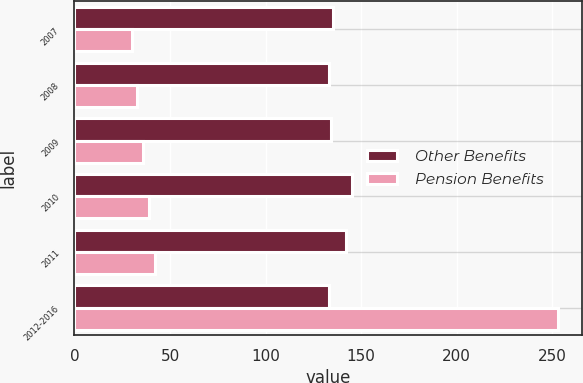Convert chart to OTSL. <chart><loc_0><loc_0><loc_500><loc_500><stacked_bar_chart><ecel><fcel>2007<fcel>2008<fcel>2009<fcel>2010<fcel>2011<fcel>2012-2016<nl><fcel>Other Benefits<fcel>135<fcel>133<fcel>134<fcel>145<fcel>142<fcel>133<nl><fcel>Pension Benefits<fcel>30<fcel>33<fcel>36<fcel>39<fcel>42<fcel>253<nl></chart> 